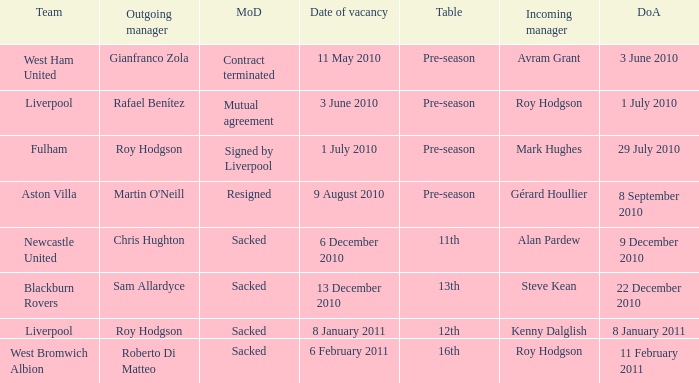What is the table for the team Blackburn Rovers? 13th. 